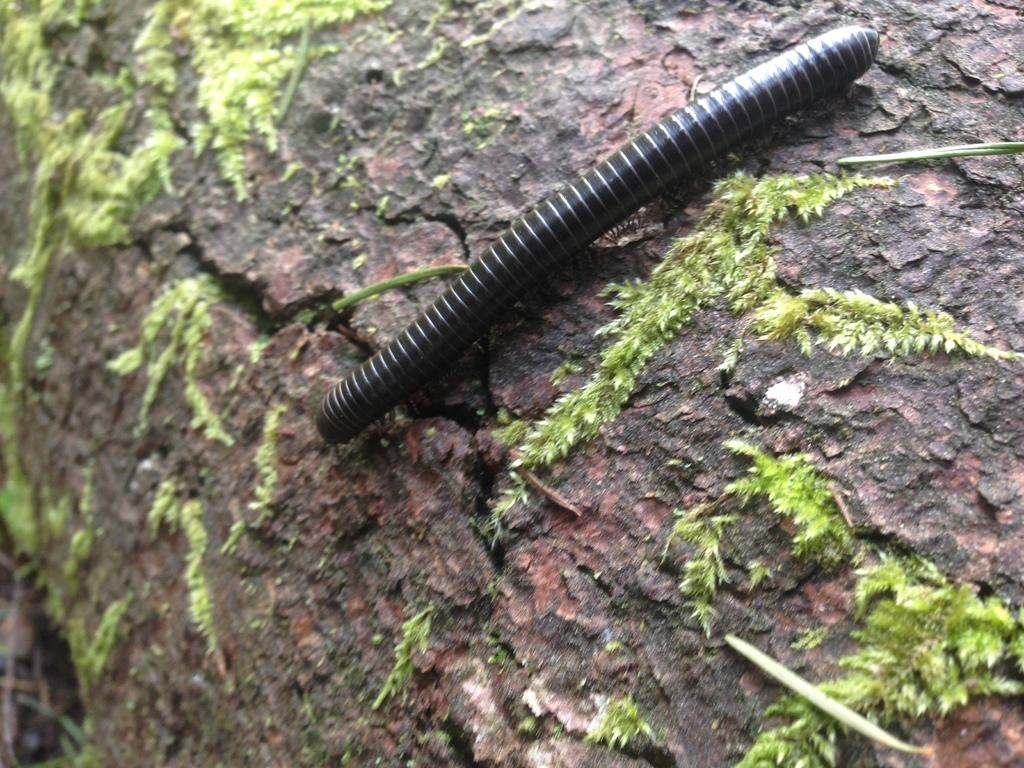What type of creature is on the stone in the image? There is a black worm on the stone in the image. What else can be seen on the stone besides the worm? There is algae on the stone beside the worm. How many toys are present in the image? There are no toys present in the image. Can you see the person taking the selfie in the image? There is no person taking a selfie in the image. 